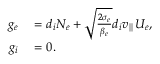Convert formula to latex. <formula><loc_0><loc_0><loc_500><loc_500>\begin{array} { r l } { g _ { e } } & = d _ { i } N _ { e } + \sqrt { \frac { 2 \sigma _ { e } } { \beta _ { e } } } d _ { i } v _ { \| } U _ { e } , } \\ { g _ { i } } & = 0 . } \end{array}</formula> 